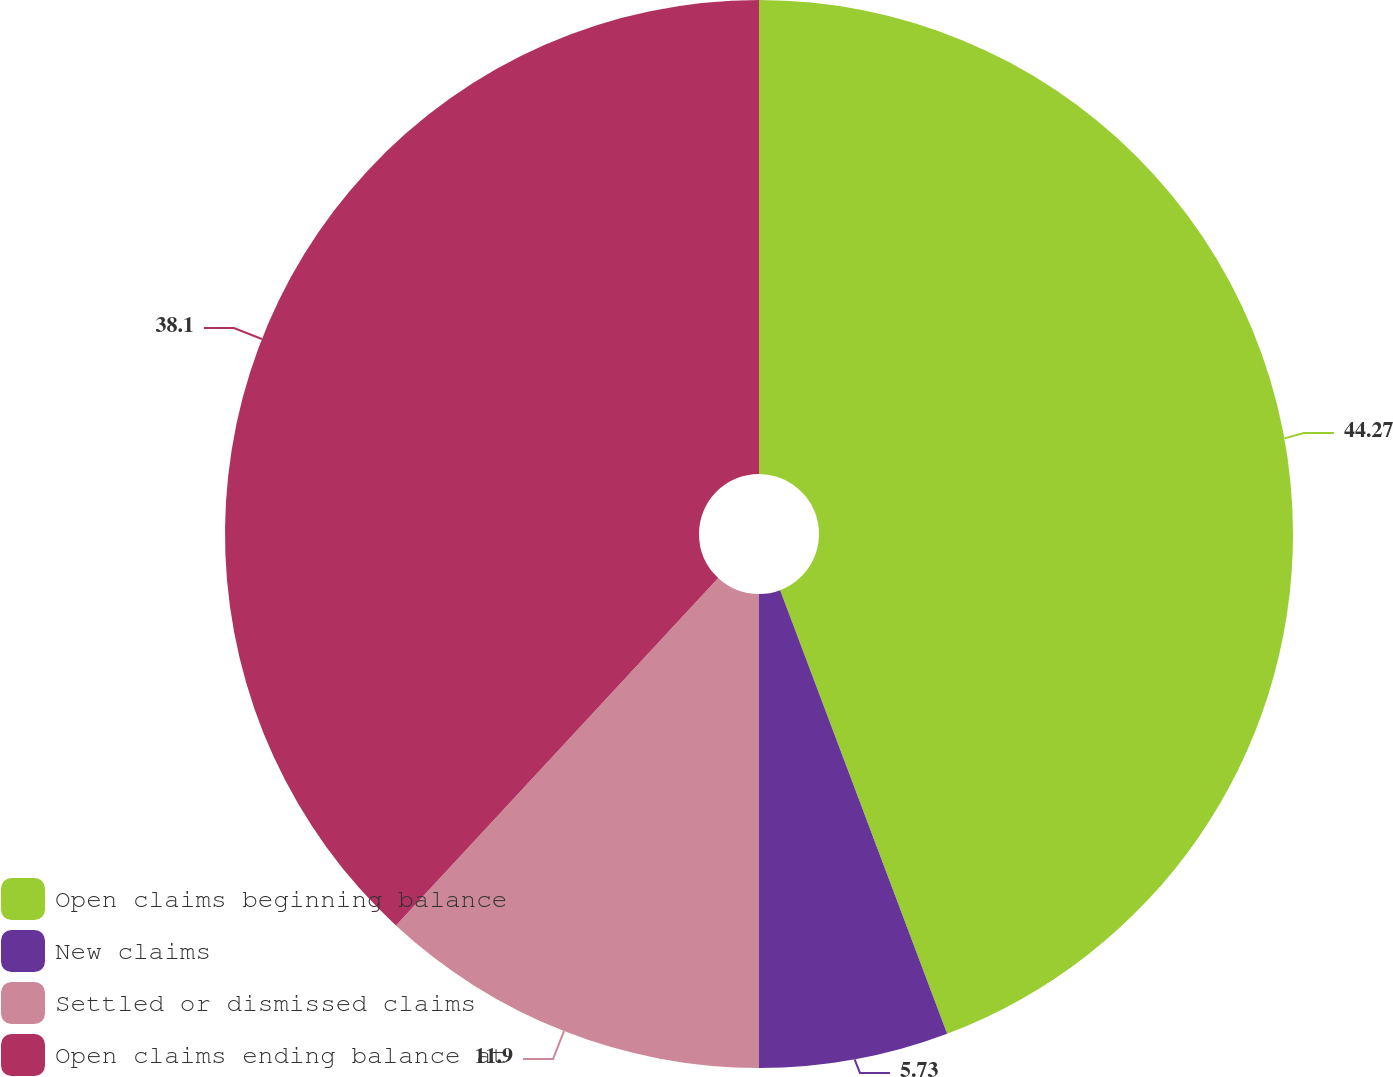Convert chart to OTSL. <chart><loc_0><loc_0><loc_500><loc_500><pie_chart><fcel>Open claims beginning balance<fcel>New claims<fcel>Settled or dismissed claims<fcel>Open claims ending balance at<nl><fcel>44.27%<fcel>5.73%<fcel>11.9%<fcel>38.1%<nl></chart> 